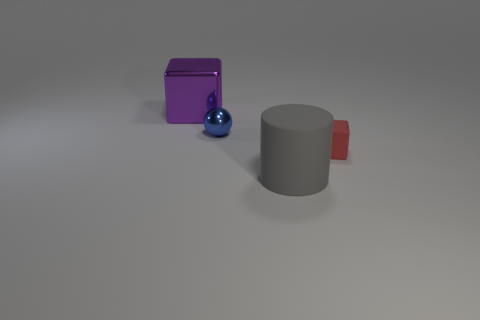Subtract all purple blocks. How many blocks are left? 1 Subtract all balls. How many objects are left? 3 Add 2 gray matte balls. How many objects exist? 6 Subtract 1 balls. How many balls are left? 0 Subtract all large cyan matte objects. Subtract all red matte cubes. How many objects are left? 3 Add 1 gray things. How many gray things are left? 2 Add 2 red matte things. How many red matte things exist? 3 Subtract 0 purple spheres. How many objects are left? 4 Subtract all green spheres. Subtract all gray cubes. How many spheres are left? 1 Subtract all green cubes. How many green cylinders are left? 0 